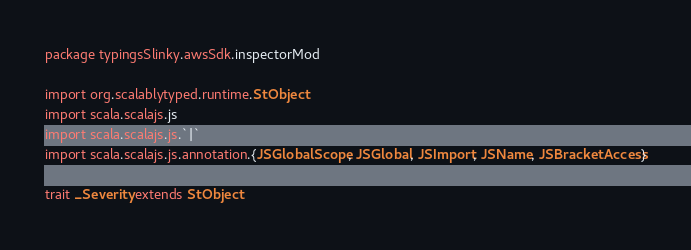<code> <loc_0><loc_0><loc_500><loc_500><_Scala_>package typingsSlinky.awsSdk.inspectorMod

import org.scalablytyped.runtime.StObject
import scala.scalajs.js
import scala.scalajs.js.`|`
import scala.scalajs.js.annotation.{JSGlobalScope, JSGlobal, JSImport, JSName, JSBracketAccess}

trait _Severity extends StObject
</code> 